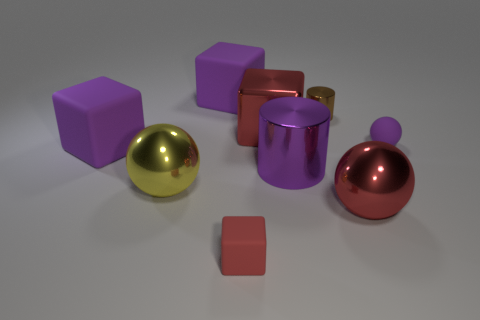There is a tiny brown object that is the same material as the big red ball; what is its shape?
Your answer should be very brief. Cylinder. Is there any other thing that has the same shape as the yellow metal object?
Your answer should be compact. Yes. The large sphere on the left side of the purple object behind the red metal thing behind the small purple matte object is what color?
Make the answer very short. Yellow. Is the number of big purple matte things that are behind the tiny purple rubber ball less than the number of red matte things on the right side of the small red rubber block?
Your response must be concise. No. Is the small purple thing the same shape as the brown object?
Make the answer very short. No. How many purple matte cubes are the same size as the metallic block?
Provide a short and direct response. 2. Is the number of yellow metal spheres behind the purple rubber ball less than the number of matte things?
Your response must be concise. Yes. What is the size of the purple rubber block that is to the left of the big metallic sphere on the left side of the big purple cylinder?
Make the answer very short. Large. What number of things are shiny cylinders or small red objects?
Offer a very short reply. 3. Is there a tiny rubber cube that has the same color as the tiny cylinder?
Make the answer very short. No. 